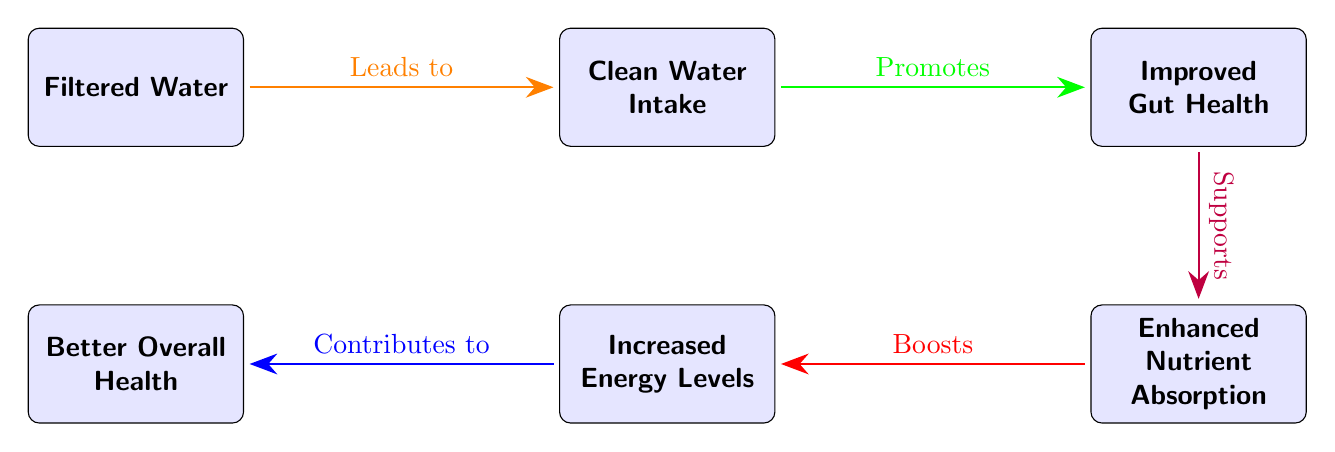What is the first node in the diagram? The first node is "Filtered Water", which is positioned at the start of the flow.
Answer: Filtered Water What does "Filtered Water" lead to? There is an arrow labeled "Leads to" from "Filtered Water" pointing to "Clean Water Intake", indicating that it results in this node.
Answer: Clean Water Intake How many nodes are in the diagram? There are five nodes in total, which include Filtered Water, Clean Water Intake, Gut Health, Nutrient Absorption, Energy Levels, and Overall Health.
Answer: 5 What effect does "Gut Health" have on "Nutrient Absorption"? The arrow from "Gut Health" to "Nutrient Absorption” is labeled "Supports," indicating a supportive relationship; hence, "Gut Health" supports "Nutrient Absorption."
Answer: Supports Which node is directly below "Gut Health"? The node directly below "Gut Health" is "Nutrient Absorption," as it is positioned directly downwards in the layout.
Answer: Nutrient Absorption What does "Nutrient Absorption" boost? The arrow from "Nutrient Absorption" to "Energy Levels" is labeled "Boosts," indicating that it has a boosting effect on "Energy Levels."
Answer: Energy Levels What is the relationship between "Energy Levels" and "Overall Health"? The arrow leading from "Energy Levels" to "Overall Health" is labeled "Contributes to," showing that "Energy Levels" contribute positively to "Overall Health."
Answer: Contributes to How does "Clean Water Intake" promote health? The arrow from "Clean Water Intake" to "Gut Health" is labeled "Promotes," indicating that it promotes improved gut health, which is beneficial for overall health.
Answer: Promotes Which node is located to the left of "Nutrient Absorption"? The node is "Energy Levels," which is directly positioned to the left of "Nutrient Absorption" in the diagram.
Answer: Energy Levels 